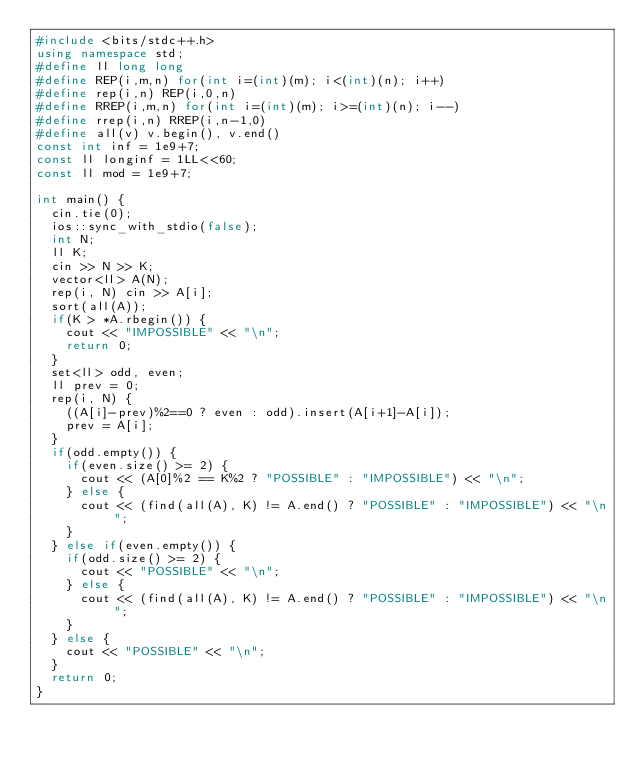<code> <loc_0><loc_0><loc_500><loc_500><_C++_>#include <bits/stdc++.h>
using namespace std;
#define ll long long
#define REP(i,m,n) for(int i=(int)(m); i<(int)(n); i++)
#define rep(i,n) REP(i,0,n)
#define RREP(i,m,n) for(int i=(int)(m); i>=(int)(n); i--)
#define rrep(i,n) RREP(i,n-1,0)
#define all(v) v.begin(), v.end()
const int inf = 1e9+7;
const ll longinf = 1LL<<60;
const ll mod = 1e9+7;

int main() {
  cin.tie(0);
  ios::sync_with_stdio(false);
  int N;
  ll K;
  cin >> N >> K;
  vector<ll> A(N);
  rep(i, N) cin >> A[i];
  sort(all(A));
  if(K > *A.rbegin()) {
    cout << "IMPOSSIBLE" << "\n";
    return 0;
  }
  set<ll> odd, even;
  ll prev = 0;
  rep(i, N) {
    ((A[i]-prev)%2==0 ? even : odd).insert(A[i+1]-A[i]);
    prev = A[i];
  }
  if(odd.empty()) {
    if(even.size() >= 2) {
      cout << (A[0]%2 == K%2 ? "POSSIBLE" : "IMPOSSIBLE") << "\n";
    } else {
      cout << (find(all(A), K) != A.end() ? "POSSIBLE" : "IMPOSSIBLE") << "\n";
    }
  } else if(even.empty()) {
    if(odd.size() >= 2) {
      cout << "POSSIBLE" << "\n";
    } else {
      cout << (find(all(A), K) != A.end() ? "POSSIBLE" : "IMPOSSIBLE") << "\n";
    }
  } else {
    cout << "POSSIBLE" << "\n";
  }
  return 0;
}
</code> 